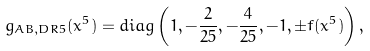Convert formula to latex. <formula><loc_0><loc_0><loc_500><loc_500>g _ { A B , D R 5 } ( x ^ { 5 } ) = d i a g \left ( 1 , - \frac { 2 } { 2 5 } , - \frac { 4 } { 2 5 } , - 1 , \pm f ( x ^ { 5 } ) \right ) ,</formula> 